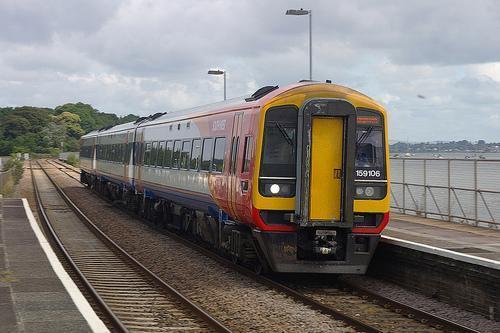How many trains are there?
Give a very brief answer. 1. 